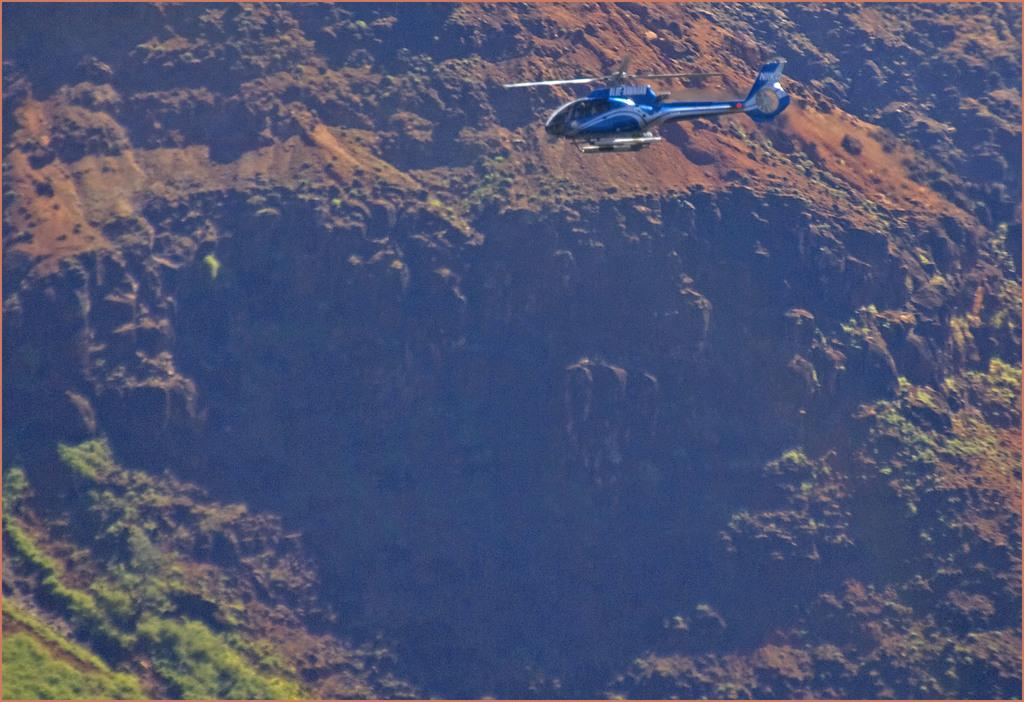What is flying in the sky in the image? There is a helicopter in the sky in the image. Can you describe the helicopter in the image? The helicopter is in the image. What type of landscape can be seen in the image? There are hills in the image. What is covering the ground on the hills? The ground on the hills is covered with grass. Can you see a snail crawling on the grass in the image? There is no snail present in the image; it only features a helicopter in the sky and hills covered with grass. 